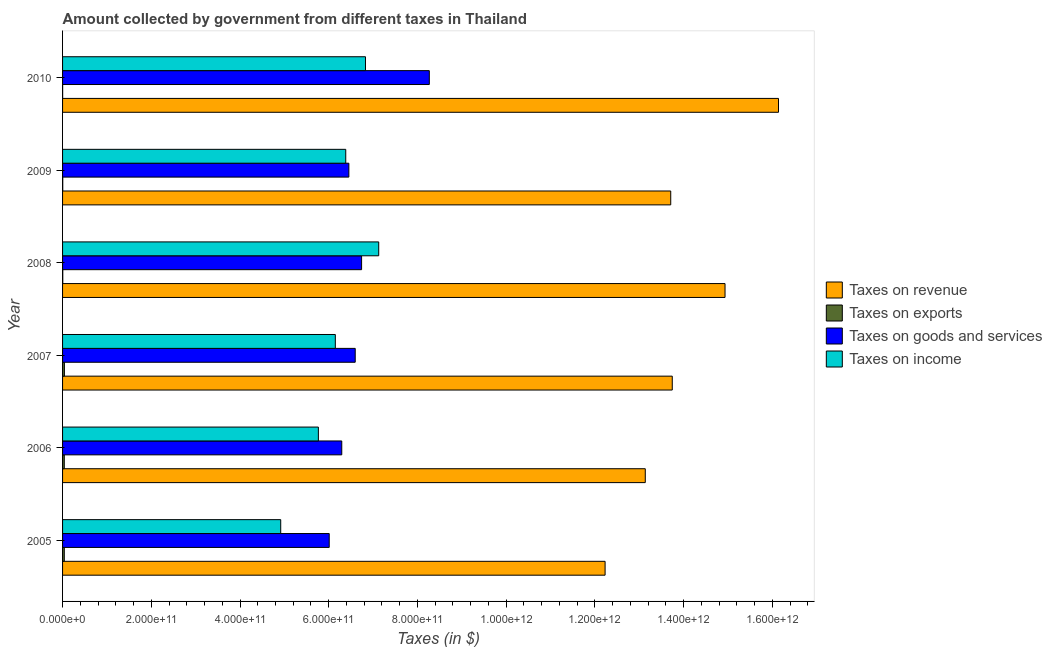Are the number of bars on each tick of the Y-axis equal?
Offer a very short reply. Yes. What is the label of the 6th group of bars from the top?
Offer a terse response. 2005. In how many cases, is the number of bars for a given year not equal to the number of legend labels?
Offer a very short reply. 0. What is the amount collected as tax on revenue in 2008?
Ensure brevity in your answer.  1.49e+12. Across all years, what is the maximum amount collected as tax on goods?
Offer a terse response. 8.27e+11. Across all years, what is the minimum amount collected as tax on income?
Ensure brevity in your answer.  4.92e+11. In which year was the amount collected as tax on goods minimum?
Your answer should be very brief. 2005. What is the total amount collected as tax on goods in the graph?
Offer a terse response. 4.04e+12. What is the difference between the amount collected as tax on goods in 2007 and that in 2010?
Provide a short and direct response. -1.67e+11. What is the difference between the amount collected as tax on exports in 2009 and the amount collected as tax on income in 2005?
Offer a terse response. -4.91e+11. What is the average amount collected as tax on income per year?
Provide a succinct answer. 6.20e+11. In the year 2009, what is the difference between the amount collected as tax on income and amount collected as tax on revenue?
Provide a short and direct response. -7.33e+11. In how many years, is the amount collected as tax on revenue greater than 200000000000 $?
Provide a succinct answer. 6. What is the ratio of the amount collected as tax on revenue in 2006 to that in 2007?
Ensure brevity in your answer.  0.96. Is the difference between the amount collected as tax on exports in 2008 and 2009 greater than the difference between the amount collected as tax on goods in 2008 and 2009?
Offer a terse response. No. What is the difference between the highest and the second highest amount collected as tax on exports?
Your answer should be very brief. 2.76e+08. What is the difference between the highest and the lowest amount collected as tax on revenue?
Keep it short and to the point. 3.91e+11. What does the 1st bar from the top in 2005 represents?
Ensure brevity in your answer.  Taxes on income. What does the 2nd bar from the bottom in 2008 represents?
Provide a succinct answer. Taxes on exports. How many years are there in the graph?
Your answer should be compact. 6. What is the difference between two consecutive major ticks on the X-axis?
Your answer should be compact. 2.00e+11. Does the graph contain grids?
Give a very brief answer. No. How many legend labels are there?
Your response must be concise. 4. What is the title of the graph?
Offer a very short reply. Amount collected by government from different taxes in Thailand. What is the label or title of the X-axis?
Make the answer very short. Taxes (in $). What is the label or title of the Y-axis?
Your answer should be very brief. Year. What is the Taxes (in $) of Taxes on revenue in 2005?
Your response must be concise. 1.22e+12. What is the Taxes (in $) of Taxes on exports in 2005?
Keep it short and to the point. 3.89e+09. What is the Taxes (in $) of Taxes on goods and services in 2005?
Provide a succinct answer. 6.01e+11. What is the Taxes (in $) of Taxes on income in 2005?
Ensure brevity in your answer.  4.92e+11. What is the Taxes (in $) in Taxes on revenue in 2006?
Provide a short and direct response. 1.31e+12. What is the Taxes (in $) in Taxes on exports in 2006?
Your answer should be very brief. 3.88e+09. What is the Taxes (in $) in Taxes on goods and services in 2006?
Keep it short and to the point. 6.29e+11. What is the Taxes (in $) in Taxes on income in 2006?
Provide a short and direct response. 5.77e+11. What is the Taxes (in $) of Taxes on revenue in 2007?
Your answer should be very brief. 1.37e+12. What is the Taxes (in $) in Taxes on exports in 2007?
Keep it short and to the point. 4.16e+09. What is the Taxes (in $) of Taxes on goods and services in 2007?
Provide a short and direct response. 6.60e+11. What is the Taxes (in $) in Taxes on income in 2007?
Your answer should be compact. 6.15e+11. What is the Taxes (in $) of Taxes on revenue in 2008?
Keep it short and to the point. 1.49e+12. What is the Taxes (in $) of Taxes on goods and services in 2008?
Keep it short and to the point. 6.74e+11. What is the Taxes (in $) of Taxes on income in 2008?
Offer a terse response. 7.13e+11. What is the Taxes (in $) of Taxes on revenue in 2009?
Provide a succinct answer. 1.37e+12. What is the Taxes (in $) in Taxes on exports in 2009?
Give a very brief answer. 4.00e+08. What is the Taxes (in $) of Taxes on goods and services in 2009?
Keep it short and to the point. 6.45e+11. What is the Taxes (in $) of Taxes on income in 2009?
Your response must be concise. 6.38e+11. What is the Taxes (in $) in Taxes on revenue in 2010?
Your answer should be compact. 1.61e+12. What is the Taxes (in $) in Taxes on exports in 2010?
Provide a succinct answer. 1.68e+08. What is the Taxes (in $) of Taxes on goods and services in 2010?
Ensure brevity in your answer.  8.27e+11. What is the Taxes (in $) in Taxes on income in 2010?
Provide a succinct answer. 6.83e+11. Across all years, what is the maximum Taxes (in $) of Taxes on revenue?
Provide a short and direct response. 1.61e+12. Across all years, what is the maximum Taxes (in $) in Taxes on exports?
Keep it short and to the point. 4.16e+09. Across all years, what is the maximum Taxes (in $) of Taxes on goods and services?
Your answer should be compact. 8.27e+11. Across all years, what is the maximum Taxes (in $) of Taxes on income?
Provide a succinct answer. 7.13e+11. Across all years, what is the minimum Taxes (in $) in Taxes on revenue?
Make the answer very short. 1.22e+12. Across all years, what is the minimum Taxes (in $) of Taxes on exports?
Your answer should be compact. 1.68e+08. Across all years, what is the minimum Taxes (in $) in Taxes on goods and services?
Provide a succinct answer. 6.01e+11. Across all years, what is the minimum Taxes (in $) of Taxes on income?
Your response must be concise. 4.92e+11. What is the total Taxes (in $) in Taxes on revenue in the graph?
Provide a short and direct response. 8.39e+12. What is the total Taxes (in $) of Taxes on exports in the graph?
Make the answer very short. 1.30e+1. What is the total Taxes (in $) of Taxes on goods and services in the graph?
Your answer should be compact. 4.04e+12. What is the total Taxes (in $) of Taxes on income in the graph?
Ensure brevity in your answer.  3.72e+12. What is the difference between the Taxes (in $) of Taxes on revenue in 2005 and that in 2006?
Keep it short and to the point. -9.06e+1. What is the difference between the Taxes (in $) in Taxes on exports in 2005 and that in 2006?
Give a very brief answer. 8.15e+06. What is the difference between the Taxes (in $) of Taxes on goods and services in 2005 and that in 2006?
Offer a very short reply. -2.83e+1. What is the difference between the Taxes (in $) of Taxes on income in 2005 and that in 2006?
Offer a terse response. -8.49e+1. What is the difference between the Taxes (in $) in Taxes on revenue in 2005 and that in 2007?
Your answer should be compact. -1.51e+11. What is the difference between the Taxes (in $) in Taxes on exports in 2005 and that in 2007?
Offer a very short reply. -2.76e+08. What is the difference between the Taxes (in $) in Taxes on goods and services in 2005 and that in 2007?
Make the answer very short. -5.86e+1. What is the difference between the Taxes (in $) of Taxes on income in 2005 and that in 2007?
Provide a short and direct response. -1.23e+11. What is the difference between the Taxes (in $) of Taxes on revenue in 2005 and that in 2008?
Ensure brevity in your answer.  -2.70e+11. What is the difference between the Taxes (in $) in Taxes on exports in 2005 and that in 2008?
Make the answer very short. 3.39e+09. What is the difference between the Taxes (in $) of Taxes on goods and services in 2005 and that in 2008?
Your answer should be very brief. -7.30e+1. What is the difference between the Taxes (in $) in Taxes on income in 2005 and that in 2008?
Your answer should be compact. -2.21e+11. What is the difference between the Taxes (in $) in Taxes on revenue in 2005 and that in 2009?
Your response must be concise. -1.48e+11. What is the difference between the Taxes (in $) of Taxes on exports in 2005 and that in 2009?
Keep it short and to the point. 3.49e+09. What is the difference between the Taxes (in $) in Taxes on goods and services in 2005 and that in 2009?
Make the answer very short. -4.43e+1. What is the difference between the Taxes (in $) of Taxes on income in 2005 and that in 2009?
Keep it short and to the point. -1.47e+11. What is the difference between the Taxes (in $) in Taxes on revenue in 2005 and that in 2010?
Make the answer very short. -3.91e+11. What is the difference between the Taxes (in $) in Taxes on exports in 2005 and that in 2010?
Make the answer very short. 3.72e+09. What is the difference between the Taxes (in $) of Taxes on goods and services in 2005 and that in 2010?
Your answer should be compact. -2.26e+11. What is the difference between the Taxes (in $) in Taxes on income in 2005 and that in 2010?
Provide a short and direct response. -1.91e+11. What is the difference between the Taxes (in $) in Taxes on revenue in 2006 and that in 2007?
Your response must be concise. -6.08e+1. What is the difference between the Taxes (in $) of Taxes on exports in 2006 and that in 2007?
Your answer should be very brief. -2.84e+08. What is the difference between the Taxes (in $) of Taxes on goods and services in 2006 and that in 2007?
Make the answer very short. -3.03e+1. What is the difference between the Taxes (in $) in Taxes on income in 2006 and that in 2007?
Your answer should be compact. -3.82e+1. What is the difference between the Taxes (in $) of Taxes on revenue in 2006 and that in 2008?
Ensure brevity in your answer.  -1.80e+11. What is the difference between the Taxes (in $) of Taxes on exports in 2006 and that in 2008?
Provide a succinct answer. 3.38e+09. What is the difference between the Taxes (in $) in Taxes on goods and services in 2006 and that in 2008?
Keep it short and to the point. -4.47e+1. What is the difference between the Taxes (in $) of Taxes on income in 2006 and that in 2008?
Offer a terse response. -1.36e+11. What is the difference between the Taxes (in $) of Taxes on revenue in 2006 and that in 2009?
Your answer should be compact. -5.74e+1. What is the difference between the Taxes (in $) in Taxes on exports in 2006 and that in 2009?
Make the answer very short. 3.48e+09. What is the difference between the Taxes (in $) in Taxes on goods and services in 2006 and that in 2009?
Your answer should be compact. -1.60e+1. What is the difference between the Taxes (in $) in Taxes on income in 2006 and that in 2009?
Your answer should be compact. -6.17e+1. What is the difference between the Taxes (in $) in Taxes on revenue in 2006 and that in 2010?
Make the answer very short. -3.00e+11. What is the difference between the Taxes (in $) of Taxes on exports in 2006 and that in 2010?
Ensure brevity in your answer.  3.71e+09. What is the difference between the Taxes (in $) of Taxes on goods and services in 2006 and that in 2010?
Provide a short and direct response. -1.97e+11. What is the difference between the Taxes (in $) of Taxes on income in 2006 and that in 2010?
Keep it short and to the point. -1.06e+11. What is the difference between the Taxes (in $) of Taxes on revenue in 2007 and that in 2008?
Offer a very short reply. -1.19e+11. What is the difference between the Taxes (in $) in Taxes on exports in 2007 and that in 2008?
Make the answer very short. 3.66e+09. What is the difference between the Taxes (in $) of Taxes on goods and services in 2007 and that in 2008?
Offer a terse response. -1.44e+1. What is the difference between the Taxes (in $) in Taxes on income in 2007 and that in 2008?
Provide a succinct answer. -9.78e+1. What is the difference between the Taxes (in $) of Taxes on revenue in 2007 and that in 2009?
Keep it short and to the point. 3.46e+09. What is the difference between the Taxes (in $) of Taxes on exports in 2007 and that in 2009?
Provide a short and direct response. 3.76e+09. What is the difference between the Taxes (in $) of Taxes on goods and services in 2007 and that in 2009?
Make the answer very short. 1.43e+1. What is the difference between the Taxes (in $) of Taxes on income in 2007 and that in 2009?
Your answer should be very brief. -2.35e+1. What is the difference between the Taxes (in $) in Taxes on revenue in 2007 and that in 2010?
Your answer should be very brief. -2.40e+11. What is the difference between the Taxes (in $) in Taxes on exports in 2007 and that in 2010?
Offer a very short reply. 4.00e+09. What is the difference between the Taxes (in $) of Taxes on goods and services in 2007 and that in 2010?
Offer a terse response. -1.67e+11. What is the difference between the Taxes (in $) of Taxes on income in 2007 and that in 2010?
Ensure brevity in your answer.  -6.80e+1. What is the difference between the Taxes (in $) in Taxes on revenue in 2008 and that in 2009?
Provide a succinct answer. 1.22e+11. What is the difference between the Taxes (in $) in Taxes on exports in 2008 and that in 2009?
Ensure brevity in your answer.  9.98e+07. What is the difference between the Taxes (in $) in Taxes on goods and services in 2008 and that in 2009?
Ensure brevity in your answer.  2.87e+1. What is the difference between the Taxes (in $) of Taxes on income in 2008 and that in 2009?
Provide a short and direct response. 7.43e+1. What is the difference between the Taxes (in $) in Taxes on revenue in 2008 and that in 2010?
Ensure brevity in your answer.  -1.21e+11. What is the difference between the Taxes (in $) in Taxes on exports in 2008 and that in 2010?
Keep it short and to the point. 3.32e+08. What is the difference between the Taxes (in $) of Taxes on goods and services in 2008 and that in 2010?
Provide a short and direct response. -1.53e+11. What is the difference between the Taxes (in $) of Taxes on income in 2008 and that in 2010?
Your answer should be very brief. 2.98e+1. What is the difference between the Taxes (in $) of Taxes on revenue in 2009 and that in 2010?
Give a very brief answer. -2.43e+11. What is the difference between the Taxes (in $) of Taxes on exports in 2009 and that in 2010?
Offer a terse response. 2.33e+08. What is the difference between the Taxes (in $) in Taxes on goods and services in 2009 and that in 2010?
Your response must be concise. -1.81e+11. What is the difference between the Taxes (in $) of Taxes on income in 2009 and that in 2010?
Offer a terse response. -4.45e+1. What is the difference between the Taxes (in $) in Taxes on revenue in 2005 and the Taxes (in $) in Taxes on exports in 2006?
Make the answer very short. 1.22e+12. What is the difference between the Taxes (in $) in Taxes on revenue in 2005 and the Taxes (in $) in Taxes on goods and services in 2006?
Your response must be concise. 5.94e+11. What is the difference between the Taxes (in $) in Taxes on revenue in 2005 and the Taxes (in $) in Taxes on income in 2006?
Offer a terse response. 6.46e+11. What is the difference between the Taxes (in $) in Taxes on exports in 2005 and the Taxes (in $) in Taxes on goods and services in 2006?
Your answer should be very brief. -6.26e+11. What is the difference between the Taxes (in $) of Taxes on exports in 2005 and the Taxes (in $) of Taxes on income in 2006?
Your answer should be compact. -5.73e+11. What is the difference between the Taxes (in $) of Taxes on goods and services in 2005 and the Taxes (in $) of Taxes on income in 2006?
Offer a very short reply. 2.44e+1. What is the difference between the Taxes (in $) of Taxes on revenue in 2005 and the Taxes (in $) of Taxes on exports in 2007?
Provide a succinct answer. 1.22e+12. What is the difference between the Taxes (in $) of Taxes on revenue in 2005 and the Taxes (in $) of Taxes on goods and services in 2007?
Offer a terse response. 5.63e+11. What is the difference between the Taxes (in $) of Taxes on revenue in 2005 and the Taxes (in $) of Taxes on income in 2007?
Provide a short and direct response. 6.08e+11. What is the difference between the Taxes (in $) in Taxes on exports in 2005 and the Taxes (in $) in Taxes on goods and services in 2007?
Ensure brevity in your answer.  -6.56e+11. What is the difference between the Taxes (in $) in Taxes on exports in 2005 and the Taxes (in $) in Taxes on income in 2007?
Your answer should be very brief. -6.11e+11. What is the difference between the Taxes (in $) in Taxes on goods and services in 2005 and the Taxes (in $) in Taxes on income in 2007?
Keep it short and to the point. -1.38e+1. What is the difference between the Taxes (in $) of Taxes on revenue in 2005 and the Taxes (in $) of Taxes on exports in 2008?
Keep it short and to the point. 1.22e+12. What is the difference between the Taxes (in $) of Taxes on revenue in 2005 and the Taxes (in $) of Taxes on goods and services in 2008?
Your response must be concise. 5.49e+11. What is the difference between the Taxes (in $) in Taxes on revenue in 2005 and the Taxes (in $) in Taxes on income in 2008?
Your answer should be very brief. 5.10e+11. What is the difference between the Taxes (in $) in Taxes on exports in 2005 and the Taxes (in $) in Taxes on goods and services in 2008?
Offer a very short reply. -6.70e+11. What is the difference between the Taxes (in $) in Taxes on exports in 2005 and the Taxes (in $) in Taxes on income in 2008?
Make the answer very short. -7.09e+11. What is the difference between the Taxes (in $) of Taxes on goods and services in 2005 and the Taxes (in $) of Taxes on income in 2008?
Provide a short and direct response. -1.12e+11. What is the difference between the Taxes (in $) in Taxes on revenue in 2005 and the Taxes (in $) in Taxes on exports in 2009?
Keep it short and to the point. 1.22e+12. What is the difference between the Taxes (in $) of Taxes on revenue in 2005 and the Taxes (in $) of Taxes on goods and services in 2009?
Your answer should be compact. 5.78e+11. What is the difference between the Taxes (in $) in Taxes on revenue in 2005 and the Taxes (in $) in Taxes on income in 2009?
Your answer should be compact. 5.85e+11. What is the difference between the Taxes (in $) in Taxes on exports in 2005 and the Taxes (in $) in Taxes on goods and services in 2009?
Your answer should be very brief. -6.42e+11. What is the difference between the Taxes (in $) of Taxes on exports in 2005 and the Taxes (in $) of Taxes on income in 2009?
Keep it short and to the point. -6.35e+11. What is the difference between the Taxes (in $) of Taxes on goods and services in 2005 and the Taxes (in $) of Taxes on income in 2009?
Offer a terse response. -3.73e+1. What is the difference between the Taxes (in $) in Taxes on revenue in 2005 and the Taxes (in $) in Taxes on exports in 2010?
Ensure brevity in your answer.  1.22e+12. What is the difference between the Taxes (in $) in Taxes on revenue in 2005 and the Taxes (in $) in Taxes on goods and services in 2010?
Offer a very short reply. 3.96e+11. What is the difference between the Taxes (in $) in Taxes on revenue in 2005 and the Taxes (in $) in Taxes on income in 2010?
Your answer should be very brief. 5.40e+11. What is the difference between the Taxes (in $) of Taxes on exports in 2005 and the Taxes (in $) of Taxes on goods and services in 2010?
Give a very brief answer. -8.23e+11. What is the difference between the Taxes (in $) in Taxes on exports in 2005 and the Taxes (in $) in Taxes on income in 2010?
Your response must be concise. -6.79e+11. What is the difference between the Taxes (in $) of Taxes on goods and services in 2005 and the Taxes (in $) of Taxes on income in 2010?
Provide a succinct answer. -8.17e+1. What is the difference between the Taxes (in $) of Taxes on revenue in 2006 and the Taxes (in $) of Taxes on exports in 2007?
Provide a short and direct response. 1.31e+12. What is the difference between the Taxes (in $) of Taxes on revenue in 2006 and the Taxes (in $) of Taxes on goods and services in 2007?
Make the answer very short. 6.54e+11. What is the difference between the Taxes (in $) of Taxes on revenue in 2006 and the Taxes (in $) of Taxes on income in 2007?
Make the answer very short. 6.99e+11. What is the difference between the Taxes (in $) in Taxes on exports in 2006 and the Taxes (in $) in Taxes on goods and services in 2007?
Keep it short and to the point. -6.56e+11. What is the difference between the Taxes (in $) of Taxes on exports in 2006 and the Taxes (in $) of Taxes on income in 2007?
Offer a terse response. -6.11e+11. What is the difference between the Taxes (in $) in Taxes on goods and services in 2006 and the Taxes (in $) in Taxes on income in 2007?
Offer a terse response. 1.45e+1. What is the difference between the Taxes (in $) of Taxes on revenue in 2006 and the Taxes (in $) of Taxes on exports in 2008?
Your answer should be very brief. 1.31e+12. What is the difference between the Taxes (in $) in Taxes on revenue in 2006 and the Taxes (in $) in Taxes on goods and services in 2008?
Give a very brief answer. 6.40e+11. What is the difference between the Taxes (in $) of Taxes on revenue in 2006 and the Taxes (in $) of Taxes on income in 2008?
Your answer should be very brief. 6.01e+11. What is the difference between the Taxes (in $) of Taxes on exports in 2006 and the Taxes (in $) of Taxes on goods and services in 2008?
Ensure brevity in your answer.  -6.70e+11. What is the difference between the Taxes (in $) of Taxes on exports in 2006 and the Taxes (in $) of Taxes on income in 2008?
Provide a short and direct response. -7.09e+11. What is the difference between the Taxes (in $) of Taxes on goods and services in 2006 and the Taxes (in $) of Taxes on income in 2008?
Your answer should be very brief. -8.33e+1. What is the difference between the Taxes (in $) of Taxes on revenue in 2006 and the Taxes (in $) of Taxes on exports in 2009?
Offer a very short reply. 1.31e+12. What is the difference between the Taxes (in $) in Taxes on revenue in 2006 and the Taxes (in $) in Taxes on goods and services in 2009?
Give a very brief answer. 6.68e+11. What is the difference between the Taxes (in $) in Taxes on revenue in 2006 and the Taxes (in $) in Taxes on income in 2009?
Keep it short and to the point. 6.75e+11. What is the difference between the Taxes (in $) in Taxes on exports in 2006 and the Taxes (in $) in Taxes on goods and services in 2009?
Offer a very short reply. -6.42e+11. What is the difference between the Taxes (in $) in Taxes on exports in 2006 and the Taxes (in $) in Taxes on income in 2009?
Your answer should be compact. -6.35e+11. What is the difference between the Taxes (in $) of Taxes on goods and services in 2006 and the Taxes (in $) of Taxes on income in 2009?
Your answer should be very brief. -9.00e+09. What is the difference between the Taxes (in $) of Taxes on revenue in 2006 and the Taxes (in $) of Taxes on exports in 2010?
Keep it short and to the point. 1.31e+12. What is the difference between the Taxes (in $) of Taxes on revenue in 2006 and the Taxes (in $) of Taxes on goods and services in 2010?
Give a very brief answer. 4.87e+11. What is the difference between the Taxes (in $) of Taxes on revenue in 2006 and the Taxes (in $) of Taxes on income in 2010?
Your answer should be compact. 6.31e+11. What is the difference between the Taxes (in $) in Taxes on exports in 2006 and the Taxes (in $) in Taxes on goods and services in 2010?
Make the answer very short. -8.23e+11. What is the difference between the Taxes (in $) in Taxes on exports in 2006 and the Taxes (in $) in Taxes on income in 2010?
Give a very brief answer. -6.79e+11. What is the difference between the Taxes (in $) in Taxes on goods and services in 2006 and the Taxes (in $) in Taxes on income in 2010?
Your answer should be compact. -5.35e+1. What is the difference between the Taxes (in $) of Taxes on revenue in 2007 and the Taxes (in $) of Taxes on exports in 2008?
Keep it short and to the point. 1.37e+12. What is the difference between the Taxes (in $) in Taxes on revenue in 2007 and the Taxes (in $) in Taxes on goods and services in 2008?
Give a very brief answer. 7.00e+11. What is the difference between the Taxes (in $) of Taxes on revenue in 2007 and the Taxes (in $) of Taxes on income in 2008?
Make the answer very short. 6.62e+11. What is the difference between the Taxes (in $) in Taxes on exports in 2007 and the Taxes (in $) in Taxes on goods and services in 2008?
Provide a short and direct response. -6.70e+11. What is the difference between the Taxes (in $) in Taxes on exports in 2007 and the Taxes (in $) in Taxes on income in 2008?
Give a very brief answer. -7.09e+11. What is the difference between the Taxes (in $) of Taxes on goods and services in 2007 and the Taxes (in $) of Taxes on income in 2008?
Keep it short and to the point. -5.30e+1. What is the difference between the Taxes (in $) of Taxes on revenue in 2007 and the Taxes (in $) of Taxes on exports in 2009?
Your answer should be compact. 1.37e+12. What is the difference between the Taxes (in $) of Taxes on revenue in 2007 and the Taxes (in $) of Taxes on goods and services in 2009?
Give a very brief answer. 7.29e+11. What is the difference between the Taxes (in $) of Taxes on revenue in 2007 and the Taxes (in $) of Taxes on income in 2009?
Provide a short and direct response. 7.36e+11. What is the difference between the Taxes (in $) of Taxes on exports in 2007 and the Taxes (in $) of Taxes on goods and services in 2009?
Make the answer very short. -6.41e+11. What is the difference between the Taxes (in $) in Taxes on exports in 2007 and the Taxes (in $) in Taxes on income in 2009?
Provide a succinct answer. -6.34e+11. What is the difference between the Taxes (in $) of Taxes on goods and services in 2007 and the Taxes (in $) of Taxes on income in 2009?
Offer a terse response. 2.13e+1. What is the difference between the Taxes (in $) of Taxes on revenue in 2007 and the Taxes (in $) of Taxes on exports in 2010?
Your answer should be very brief. 1.37e+12. What is the difference between the Taxes (in $) of Taxes on revenue in 2007 and the Taxes (in $) of Taxes on goods and services in 2010?
Your response must be concise. 5.48e+11. What is the difference between the Taxes (in $) of Taxes on revenue in 2007 and the Taxes (in $) of Taxes on income in 2010?
Offer a very short reply. 6.92e+11. What is the difference between the Taxes (in $) of Taxes on exports in 2007 and the Taxes (in $) of Taxes on goods and services in 2010?
Offer a very short reply. -8.23e+11. What is the difference between the Taxes (in $) of Taxes on exports in 2007 and the Taxes (in $) of Taxes on income in 2010?
Your response must be concise. -6.79e+11. What is the difference between the Taxes (in $) in Taxes on goods and services in 2007 and the Taxes (in $) in Taxes on income in 2010?
Make the answer very short. -2.32e+1. What is the difference between the Taxes (in $) of Taxes on revenue in 2008 and the Taxes (in $) of Taxes on exports in 2009?
Provide a short and direct response. 1.49e+12. What is the difference between the Taxes (in $) in Taxes on revenue in 2008 and the Taxes (in $) in Taxes on goods and services in 2009?
Give a very brief answer. 8.48e+11. What is the difference between the Taxes (in $) of Taxes on revenue in 2008 and the Taxes (in $) of Taxes on income in 2009?
Make the answer very short. 8.55e+11. What is the difference between the Taxes (in $) of Taxes on exports in 2008 and the Taxes (in $) of Taxes on goods and services in 2009?
Your answer should be very brief. -6.45e+11. What is the difference between the Taxes (in $) of Taxes on exports in 2008 and the Taxes (in $) of Taxes on income in 2009?
Your answer should be very brief. -6.38e+11. What is the difference between the Taxes (in $) in Taxes on goods and services in 2008 and the Taxes (in $) in Taxes on income in 2009?
Your answer should be compact. 3.57e+1. What is the difference between the Taxes (in $) of Taxes on revenue in 2008 and the Taxes (in $) of Taxes on exports in 2010?
Offer a terse response. 1.49e+12. What is the difference between the Taxes (in $) in Taxes on revenue in 2008 and the Taxes (in $) in Taxes on goods and services in 2010?
Your answer should be very brief. 6.67e+11. What is the difference between the Taxes (in $) of Taxes on revenue in 2008 and the Taxes (in $) of Taxes on income in 2010?
Provide a short and direct response. 8.11e+11. What is the difference between the Taxes (in $) in Taxes on exports in 2008 and the Taxes (in $) in Taxes on goods and services in 2010?
Your response must be concise. -8.26e+11. What is the difference between the Taxes (in $) in Taxes on exports in 2008 and the Taxes (in $) in Taxes on income in 2010?
Your response must be concise. -6.82e+11. What is the difference between the Taxes (in $) of Taxes on goods and services in 2008 and the Taxes (in $) of Taxes on income in 2010?
Your answer should be compact. -8.76e+09. What is the difference between the Taxes (in $) in Taxes on revenue in 2009 and the Taxes (in $) in Taxes on exports in 2010?
Keep it short and to the point. 1.37e+12. What is the difference between the Taxes (in $) of Taxes on revenue in 2009 and the Taxes (in $) of Taxes on goods and services in 2010?
Make the answer very short. 5.44e+11. What is the difference between the Taxes (in $) in Taxes on revenue in 2009 and the Taxes (in $) in Taxes on income in 2010?
Your answer should be very brief. 6.88e+11. What is the difference between the Taxes (in $) of Taxes on exports in 2009 and the Taxes (in $) of Taxes on goods and services in 2010?
Offer a very short reply. -8.26e+11. What is the difference between the Taxes (in $) in Taxes on exports in 2009 and the Taxes (in $) in Taxes on income in 2010?
Provide a short and direct response. -6.82e+11. What is the difference between the Taxes (in $) in Taxes on goods and services in 2009 and the Taxes (in $) in Taxes on income in 2010?
Your answer should be compact. -3.75e+1. What is the average Taxes (in $) in Taxes on revenue per year?
Provide a short and direct response. 1.40e+12. What is the average Taxes (in $) of Taxes on exports per year?
Your answer should be compact. 2.17e+09. What is the average Taxes (in $) of Taxes on goods and services per year?
Your answer should be compact. 6.73e+11. What is the average Taxes (in $) in Taxes on income per year?
Give a very brief answer. 6.20e+11. In the year 2005, what is the difference between the Taxes (in $) of Taxes on revenue and Taxes (in $) of Taxes on exports?
Keep it short and to the point. 1.22e+12. In the year 2005, what is the difference between the Taxes (in $) in Taxes on revenue and Taxes (in $) in Taxes on goods and services?
Your answer should be compact. 6.22e+11. In the year 2005, what is the difference between the Taxes (in $) in Taxes on revenue and Taxes (in $) in Taxes on income?
Keep it short and to the point. 7.31e+11. In the year 2005, what is the difference between the Taxes (in $) in Taxes on exports and Taxes (in $) in Taxes on goods and services?
Offer a very short reply. -5.97e+11. In the year 2005, what is the difference between the Taxes (in $) in Taxes on exports and Taxes (in $) in Taxes on income?
Your answer should be compact. -4.88e+11. In the year 2005, what is the difference between the Taxes (in $) of Taxes on goods and services and Taxes (in $) of Taxes on income?
Provide a short and direct response. 1.09e+11. In the year 2006, what is the difference between the Taxes (in $) of Taxes on revenue and Taxes (in $) of Taxes on exports?
Ensure brevity in your answer.  1.31e+12. In the year 2006, what is the difference between the Taxes (in $) in Taxes on revenue and Taxes (in $) in Taxes on goods and services?
Make the answer very short. 6.84e+11. In the year 2006, what is the difference between the Taxes (in $) of Taxes on revenue and Taxes (in $) of Taxes on income?
Give a very brief answer. 7.37e+11. In the year 2006, what is the difference between the Taxes (in $) of Taxes on exports and Taxes (in $) of Taxes on goods and services?
Make the answer very short. -6.26e+11. In the year 2006, what is the difference between the Taxes (in $) of Taxes on exports and Taxes (in $) of Taxes on income?
Provide a short and direct response. -5.73e+11. In the year 2006, what is the difference between the Taxes (in $) of Taxes on goods and services and Taxes (in $) of Taxes on income?
Give a very brief answer. 5.27e+1. In the year 2007, what is the difference between the Taxes (in $) in Taxes on revenue and Taxes (in $) in Taxes on exports?
Provide a succinct answer. 1.37e+12. In the year 2007, what is the difference between the Taxes (in $) in Taxes on revenue and Taxes (in $) in Taxes on goods and services?
Keep it short and to the point. 7.15e+11. In the year 2007, what is the difference between the Taxes (in $) in Taxes on revenue and Taxes (in $) in Taxes on income?
Give a very brief answer. 7.60e+11. In the year 2007, what is the difference between the Taxes (in $) in Taxes on exports and Taxes (in $) in Taxes on goods and services?
Your response must be concise. -6.56e+11. In the year 2007, what is the difference between the Taxes (in $) in Taxes on exports and Taxes (in $) in Taxes on income?
Make the answer very short. -6.11e+11. In the year 2007, what is the difference between the Taxes (in $) in Taxes on goods and services and Taxes (in $) in Taxes on income?
Provide a succinct answer. 4.48e+1. In the year 2008, what is the difference between the Taxes (in $) in Taxes on revenue and Taxes (in $) in Taxes on exports?
Keep it short and to the point. 1.49e+12. In the year 2008, what is the difference between the Taxes (in $) of Taxes on revenue and Taxes (in $) of Taxes on goods and services?
Your answer should be very brief. 8.19e+11. In the year 2008, what is the difference between the Taxes (in $) in Taxes on revenue and Taxes (in $) in Taxes on income?
Provide a succinct answer. 7.81e+11. In the year 2008, what is the difference between the Taxes (in $) in Taxes on exports and Taxes (in $) in Taxes on goods and services?
Your answer should be compact. -6.74e+11. In the year 2008, what is the difference between the Taxes (in $) in Taxes on exports and Taxes (in $) in Taxes on income?
Give a very brief answer. -7.12e+11. In the year 2008, what is the difference between the Taxes (in $) of Taxes on goods and services and Taxes (in $) of Taxes on income?
Give a very brief answer. -3.86e+1. In the year 2009, what is the difference between the Taxes (in $) in Taxes on revenue and Taxes (in $) in Taxes on exports?
Provide a succinct answer. 1.37e+12. In the year 2009, what is the difference between the Taxes (in $) of Taxes on revenue and Taxes (in $) of Taxes on goods and services?
Give a very brief answer. 7.26e+11. In the year 2009, what is the difference between the Taxes (in $) of Taxes on revenue and Taxes (in $) of Taxes on income?
Your answer should be compact. 7.33e+11. In the year 2009, what is the difference between the Taxes (in $) in Taxes on exports and Taxes (in $) in Taxes on goods and services?
Your answer should be compact. -6.45e+11. In the year 2009, what is the difference between the Taxes (in $) in Taxes on exports and Taxes (in $) in Taxes on income?
Your answer should be very brief. -6.38e+11. In the year 2009, what is the difference between the Taxes (in $) of Taxes on goods and services and Taxes (in $) of Taxes on income?
Offer a terse response. 7.00e+09. In the year 2010, what is the difference between the Taxes (in $) of Taxes on revenue and Taxes (in $) of Taxes on exports?
Give a very brief answer. 1.61e+12. In the year 2010, what is the difference between the Taxes (in $) in Taxes on revenue and Taxes (in $) in Taxes on goods and services?
Give a very brief answer. 7.87e+11. In the year 2010, what is the difference between the Taxes (in $) in Taxes on revenue and Taxes (in $) in Taxes on income?
Offer a terse response. 9.31e+11. In the year 2010, what is the difference between the Taxes (in $) in Taxes on exports and Taxes (in $) in Taxes on goods and services?
Your response must be concise. -8.27e+11. In the year 2010, what is the difference between the Taxes (in $) of Taxes on exports and Taxes (in $) of Taxes on income?
Give a very brief answer. -6.83e+11. In the year 2010, what is the difference between the Taxes (in $) in Taxes on goods and services and Taxes (in $) in Taxes on income?
Keep it short and to the point. 1.44e+11. What is the ratio of the Taxes (in $) of Taxes on revenue in 2005 to that in 2006?
Your answer should be compact. 0.93. What is the ratio of the Taxes (in $) in Taxes on exports in 2005 to that in 2006?
Your answer should be compact. 1. What is the ratio of the Taxes (in $) of Taxes on goods and services in 2005 to that in 2006?
Make the answer very short. 0.96. What is the ratio of the Taxes (in $) in Taxes on income in 2005 to that in 2006?
Make the answer very short. 0.85. What is the ratio of the Taxes (in $) of Taxes on revenue in 2005 to that in 2007?
Give a very brief answer. 0.89. What is the ratio of the Taxes (in $) in Taxes on exports in 2005 to that in 2007?
Provide a short and direct response. 0.93. What is the ratio of the Taxes (in $) of Taxes on goods and services in 2005 to that in 2007?
Provide a short and direct response. 0.91. What is the ratio of the Taxes (in $) in Taxes on income in 2005 to that in 2007?
Keep it short and to the point. 0.8. What is the ratio of the Taxes (in $) in Taxes on revenue in 2005 to that in 2008?
Your answer should be very brief. 0.82. What is the ratio of the Taxes (in $) in Taxes on exports in 2005 to that in 2008?
Keep it short and to the point. 7.78. What is the ratio of the Taxes (in $) of Taxes on goods and services in 2005 to that in 2008?
Provide a succinct answer. 0.89. What is the ratio of the Taxes (in $) in Taxes on income in 2005 to that in 2008?
Your answer should be compact. 0.69. What is the ratio of the Taxes (in $) in Taxes on revenue in 2005 to that in 2009?
Offer a terse response. 0.89. What is the ratio of the Taxes (in $) of Taxes on exports in 2005 to that in 2009?
Offer a very short reply. 9.72. What is the ratio of the Taxes (in $) in Taxes on goods and services in 2005 to that in 2009?
Provide a short and direct response. 0.93. What is the ratio of the Taxes (in $) of Taxes on income in 2005 to that in 2009?
Give a very brief answer. 0.77. What is the ratio of the Taxes (in $) of Taxes on revenue in 2005 to that in 2010?
Make the answer very short. 0.76. What is the ratio of the Taxes (in $) in Taxes on exports in 2005 to that in 2010?
Ensure brevity in your answer.  23.21. What is the ratio of the Taxes (in $) in Taxes on goods and services in 2005 to that in 2010?
Keep it short and to the point. 0.73. What is the ratio of the Taxes (in $) of Taxes on income in 2005 to that in 2010?
Offer a terse response. 0.72. What is the ratio of the Taxes (in $) of Taxes on revenue in 2006 to that in 2007?
Provide a short and direct response. 0.96. What is the ratio of the Taxes (in $) in Taxes on exports in 2006 to that in 2007?
Offer a very short reply. 0.93. What is the ratio of the Taxes (in $) of Taxes on goods and services in 2006 to that in 2007?
Your answer should be very brief. 0.95. What is the ratio of the Taxes (in $) in Taxes on income in 2006 to that in 2007?
Offer a terse response. 0.94. What is the ratio of the Taxes (in $) of Taxes on revenue in 2006 to that in 2008?
Make the answer very short. 0.88. What is the ratio of the Taxes (in $) of Taxes on exports in 2006 to that in 2008?
Ensure brevity in your answer.  7.76. What is the ratio of the Taxes (in $) of Taxes on goods and services in 2006 to that in 2008?
Your response must be concise. 0.93. What is the ratio of the Taxes (in $) of Taxes on income in 2006 to that in 2008?
Offer a terse response. 0.81. What is the ratio of the Taxes (in $) of Taxes on revenue in 2006 to that in 2009?
Give a very brief answer. 0.96. What is the ratio of the Taxes (in $) of Taxes on exports in 2006 to that in 2009?
Provide a short and direct response. 9.7. What is the ratio of the Taxes (in $) in Taxes on goods and services in 2006 to that in 2009?
Make the answer very short. 0.98. What is the ratio of the Taxes (in $) of Taxes on income in 2006 to that in 2009?
Provide a succinct answer. 0.9. What is the ratio of the Taxes (in $) in Taxes on revenue in 2006 to that in 2010?
Give a very brief answer. 0.81. What is the ratio of the Taxes (in $) of Taxes on exports in 2006 to that in 2010?
Offer a terse response. 23.16. What is the ratio of the Taxes (in $) in Taxes on goods and services in 2006 to that in 2010?
Provide a short and direct response. 0.76. What is the ratio of the Taxes (in $) in Taxes on income in 2006 to that in 2010?
Your response must be concise. 0.84. What is the ratio of the Taxes (in $) in Taxes on revenue in 2007 to that in 2008?
Keep it short and to the point. 0.92. What is the ratio of the Taxes (in $) in Taxes on exports in 2007 to that in 2008?
Make the answer very short. 8.33. What is the ratio of the Taxes (in $) of Taxes on goods and services in 2007 to that in 2008?
Provide a short and direct response. 0.98. What is the ratio of the Taxes (in $) of Taxes on income in 2007 to that in 2008?
Keep it short and to the point. 0.86. What is the ratio of the Taxes (in $) of Taxes on revenue in 2007 to that in 2009?
Offer a terse response. 1. What is the ratio of the Taxes (in $) in Taxes on exports in 2007 to that in 2009?
Keep it short and to the point. 10.41. What is the ratio of the Taxes (in $) of Taxes on goods and services in 2007 to that in 2009?
Provide a short and direct response. 1.02. What is the ratio of the Taxes (in $) of Taxes on income in 2007 to that in 2009?
Provide a short and direct response. 0.96. What is the ratio of the Taxes (in $) in Taxes on revenue in 2007 to that in 2010?
Offer a terse response. 0.85. What is the ratio of the Taxes (in $) in Taxes on exports in 2007 to that in 2010?
Offer a terse response. 24.86. What is the ratio of the Taxes (in $) of Taxes on goods and services in 2007 to that in 2010?
Provide a short and direct response. 0.8. What is the ratio of the Taxes (in $) in Taxes on income in 2007 to that in 2010?
Provide a succinct answer. 0.9. What is the ratio of the Taxes (in $) in Taxes on revenue in 2008 to that in 2009?
Your response must be concise. 1.09. What is the ratio of the Taxes (in $) of Taxes on exports in 2008 to that in 2009?
Offer a very short reply. 1.25. What is the ratio of the Taxes (in $) of Taxes on goods and services in 2008 to that in 2009?
Ensure brevity in your answer.  1.04. What is the ratio of the Taxes (in $) in Taxes on income in 2008 to that in 2009?
Your answer should be very brief. 1.12. What is the ratio of the Taxes (in $) in Taxes on revenue in 2008 to that in 2010?
Provide a succinct answer. 0.93. What is the ratio of the Taxes (in $) of Taxes on exports in 2008 to that in 2010?
Your answer should be very brief. 2.98. What is the ratio of the Taxes (in $) of Taxes on goods and services in 2008 to that in 2010?
Give a very brief answer. 0.82. What is the ratio of the Taxes (in $) of Taxes on income in 2008 to that in 2010?
Offer a terse response. 1.04. What is the ratio of the Taxes (in $) in Taxes on revenue in 2009 to that in 2010?
Give a very brief answer. 0.85. What is the ratio of the Taxes (in $) in Taxes on exports in 2009 to that in 2010?
Keep it short and to the point. 2.39. What is the ratio of the Taxes (in $) of Taxes on goods and services in 2009 to that in 2010?
Ensure brevity in your answer.  0.78. What is the ratio of the Taxes (in $) in Taxes on income in 2009 to that in 2010?
Your answer should be compact. 0.93. What is the difference between the highest and the second highest Taxes (in $) of Taxes on revenue?
Your answer should be very brief. 1.21e+11. What is the difference between the highest and the second highest Taxes (in $) in Taxes on exports?
Provide a short and direct response. 2.76e+08. What is the difference between the highest and the second highest Taxes (in $) in Taxes on goods and services?
Provide a short and direct response. 1.53e+11. What is the difference between the highest and the second highest Taxes (in $) in Taxes on income?
Offer a very short reply. 2.98e+1. What is the difference between the highest and the lowest Taxes (in $) in Taxes on revenue?
Keep it short and to the point. 3.91e+11. What is the difference between the highest and the lowest Taxes (in $) in Taxes on exports?
Make the answer very short. 4.00e+09. What is the difference between the highest and the lowest Taxes (in $) in Taxes on goods and services?
Make the answer very short. 2.26e+11. What is the difference between the highest and the lowest Taxes (in $) of Taxes on income?
Provide a short and direct response. 2.21e+11. 